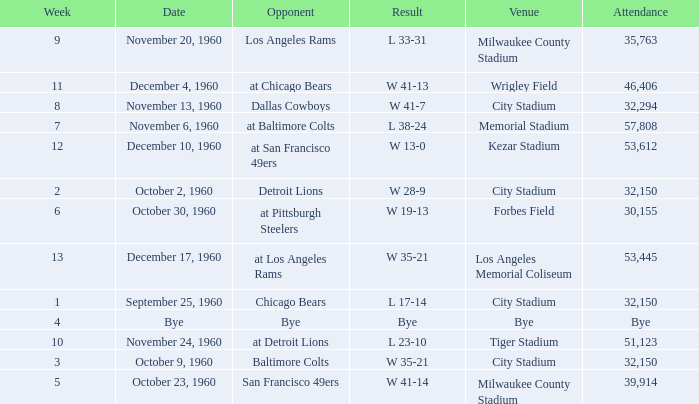What number of people went to the tiger stadium L 23-10. 